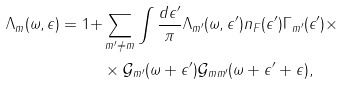<formula> <loc_0><loc_0><loc_500><loc_500>\Lambda _ { m } ( \omega , \epsilon ) = 1 + & \sum _ { m ^ { \prime } \neq m } \int \frac { d \epsilon ^ { \prime } } { \pi } \Lambda _ { m ^ { \prime } } ( \omega , \epsilon ^ { \prime } ) n _ { F } ( \epsilon ^ { \prime } ) \Gamma _ { m ^ { \prime } } ( \epsilon ^ { \prime } ) \times \\ & \times \mathcal { G } _ { m ^ { \prime } } ( \omega + \epsilon ^ { \prime } ) \mathcal { G } _ { m m ^ { \prime } } ( \omega + \epsilon ^ { \prime } + \epsilon ) ,</formula> 